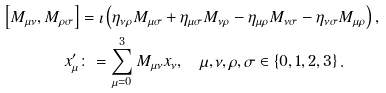Convert formula to latex. <formula><loc_0><loc_0><loc_500><loc_500>\left [ M _ { \mu \nu } , M _ { \rho \sigma } \right ] & = \imath \left ( \eta _ { \nu \rho } M _ { \mu \sigma } + \eta _ { \mu \sigma } M _ { \nu \rho } - \eta _ { \mu \rho } M _ { \nu \sigma } - \eta _ { \nu \sigma } M _ { \mu \rho } \right ) , \\ x _ { \mu } ^ { \prime } & \colon = \sum _ { \mu = 0 } ^ { 3 } M _ { \mu \nu } x _ { \nu } , \quad \mu , \nu , \rho , \sigma \in \left \{ 0 , 1 , 2 , 3 \right \} .</formula> 